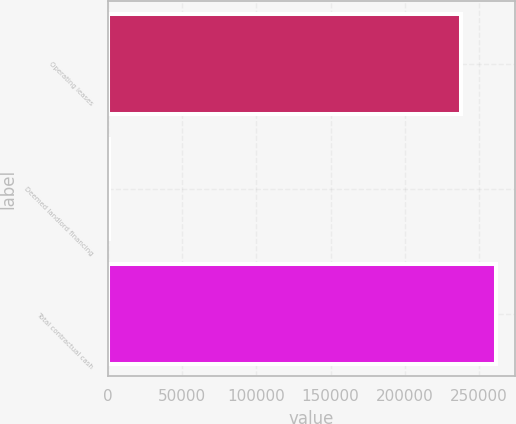Convert chart to OTSL. <chart><loc_0><loc_0><loc_500><loc_500><bar_chart><fcel>Operating leases<fcel>Deemed landlord financing<fcel>Total contractual cash<nl><fcel>237496<fcel>794<fcel>261309<nl></chart> 